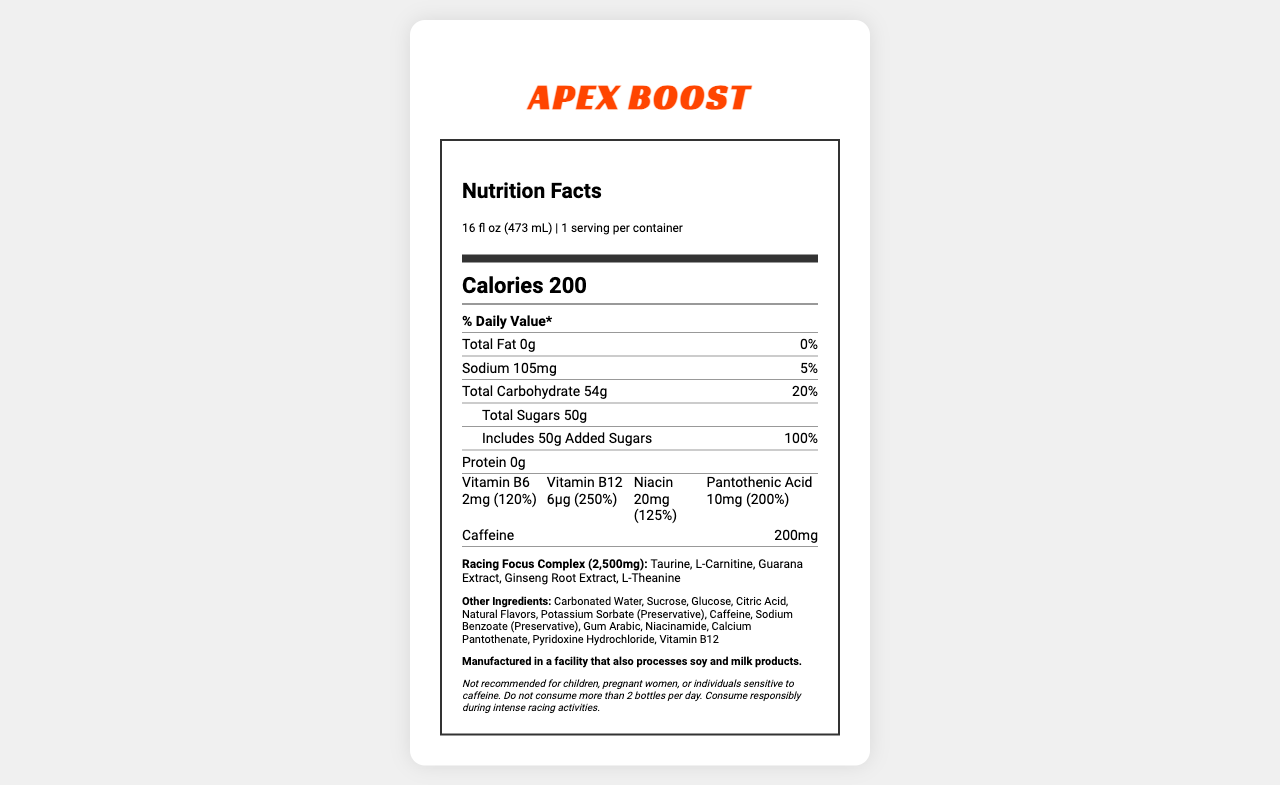what is the serving size of Apex Boost? The serving size is clearly indicated as 16 fl oz (473 mL) in the document.
Answer: 16 fl oz (473 mL) how many calories are in one serving? The document states that there are 200 calories in one serving.
Answer: 200 what is the total carbohydrate content? The document lists the total carbohydrate content as 54g.
Answer: 54g how much caffeine does Apex Boost contain per serving? According to the document, Apex Boost contains 200mg of caffeine per serving.
Answer: 200mg what is the daily value percentage of Vitamin B12? The daily value percentage of Vitamin B12 is listed as 250% in the document.
Answer: 250% which of the following ingredients is included in the proprietary blend? A. Taurine B. Calcium Pantothenate C. Citric Acid D. Sucrose The proprietary blend, Racing Focus Complex, includes Taurine as one of its ingredients.
Answer: A. Taurine how many servings are in one container? A. 1 B. 2 C. 3 D. 4 The document specifies that there is 1 serving per container.
Answer: A. 1 is Apex Boost recommended for children? The disclaimer section states that the product is not recommended for children.
Answer: No summarize the main nutritional highlights of Apex Boost. Apex Boost is formulated to provide energy and focus, making it suitable for intense racing activities. The drink offers high amounts of sugar and caffeine and is fortified with essential vitamins. The proprietary blend of ingredients aims to enhance mental focus and energy levels.
Answer: Apex Boost is a high-performance energy drink with 200 calories per 16 fl oz serving. It contains 54g of carbohydrates, including 50g of added sugars, and 200mg of caffeine. The drink also includes significant amounts of Vitamins B6, B12, Niacin, and Pantothenic Acid, and features a proprietary blend called Racing Focus Complex. what are the main sources of sugar in Apex Boost? The document lists Sucrose and Glucose as part of the other ingredients, making them the main sources of sugar.
Answer: Sucrose and Glucose what facility condition should people with soy or milk allergies be aware of? The allergen information section specifies that the product is made in a facility that processes soy and milk products.
Answer: Manufactured in a facility that also processes soy and milk products. can the exact effects of the Racing Focus Complex be determined from the provided document? While the ingredients of the Racing Focus Complex are listed, their individual effects and the overall impact of the blend are not detailed in the document. Therefore, the exact effects cannot be determined.
Answer: Not enough information 